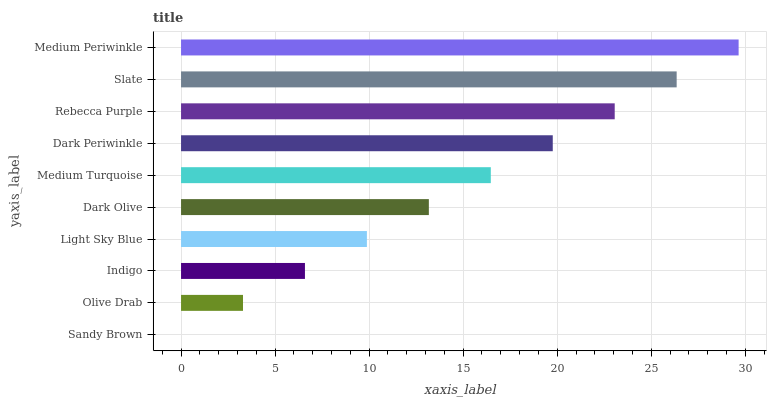Is Sandy Brown the minimum?
Answer yes or no. Yes. Is Medium Periwinkle the maximum?
Answer yes or no. Yes. Is Olive Drab the minimum?
Answer yes or no. No. Is Olive Drab the maximum?
Answer yes or no. No. Is Olive Drab greater than Sandy Brown?
Answer yes or no. Yes. Is Sandy Brown less than Olive Drab?
Answer yes or no. Yes. Is Sandy Brown greater than Olive Drab?
Answer yes or no. No. Is Olive Drab less than Sandy Brown?
Answer yes or no. No. Is Medium Turquoise the high median?
Answer yes or no. Yes. Is Dark Olive the low median?
Answer yes or no. Yes. Is Slate the high median?
Answer yes or no. No. Is Light Sky Blue the low median?
Answer yes or no. No. 